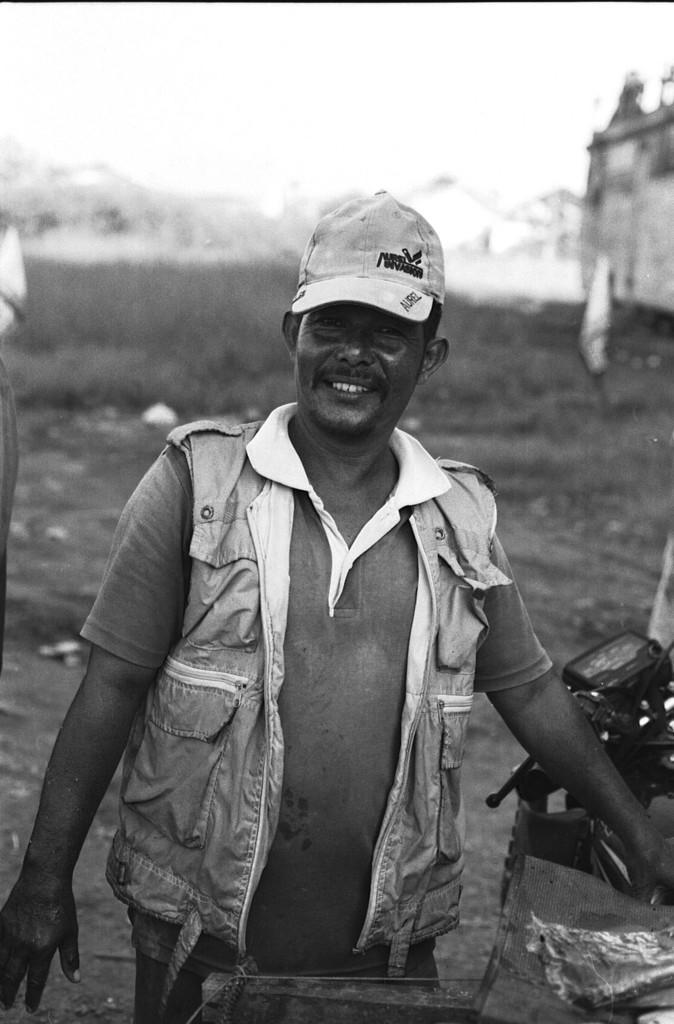How would you summarize this image in a sentence or two? In this image there is a person wearing a cap and standing beside a motor vehicle, there is a building, grass and mountains covered with snow. 